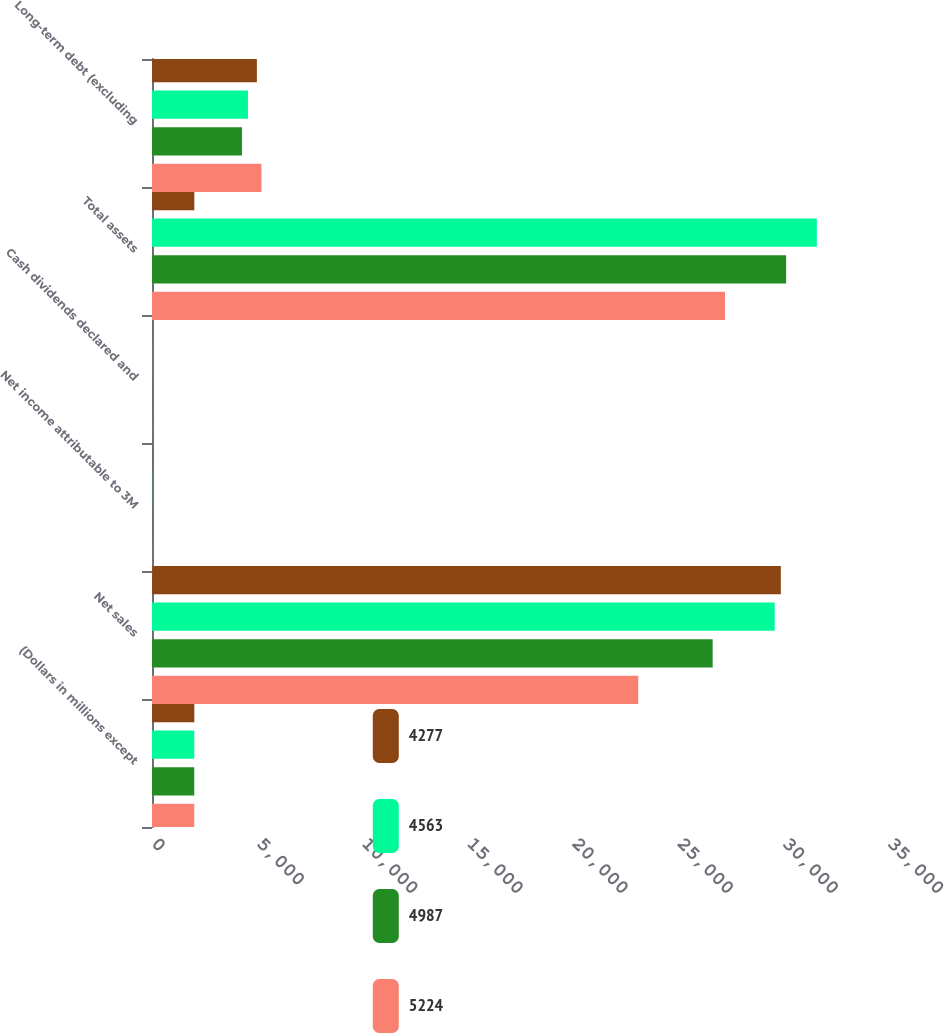Convert chart. <chart><loc_0><loc_0><loc_500><loc_500><stacked_bar_chart><ecel><fcel>(Dollars in millions except<fcel>Net sales<fcel>Net income attributable to 3M<fcel>Cash dividends declared and<fcel>Total assets<fcel>Long-term debt (excluding<nl><fcel>4277<fcel>2012<fcel>29904<fcel>6.32<fcel>2.36<fcel>2012<fcel>4987<nl><fcel>4563<fcel>2011<fcel>29611<fcel>5.96<fcel>2.2<fcel>31616<fcel>4563<nl><fcel>4987<fcel>2010<fcel>26662<fcel>5.63<fcel>2.1<fcel>30156<fcel>4277<nl><fcel>5224<fcel>2009<fcel>23123<fcel>4.52<fcel>2.04<fcel>27250<fcel>5204<nl></chart> 